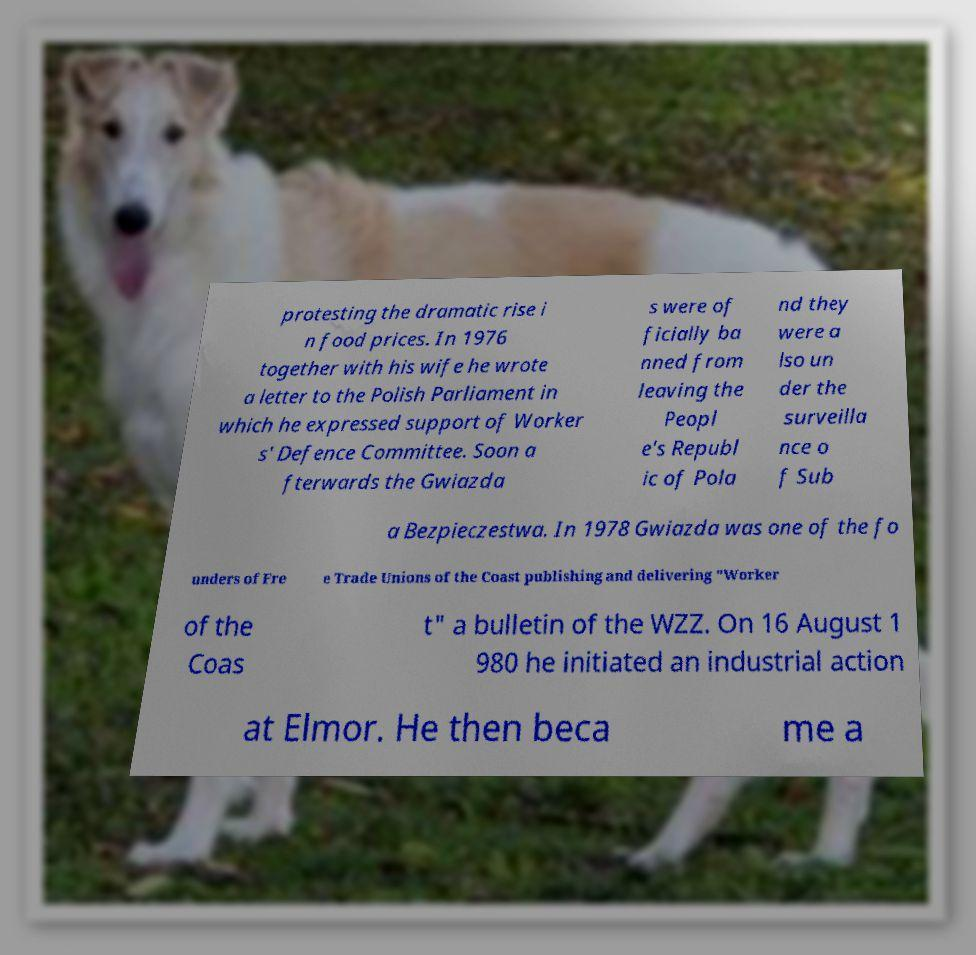There's text embedded in this image that I need extracted. Can you transcribe it verbatim? protesting the dramatic rise i n food prices. In 1976 together with his wife he wrote a letter to the Polish Parliament in which he expressed support of Worker s' Defence Committee. Soon a fterwards the Gwiazda s were of ficially ba nned from leaving the Peopl e's Republ ic of Pola nd they were a lso un der the surveilla nce o f Sub a Bezpieczestwa. In 1978 Gwiazda was one of the fo unders of Fre e Trade Unions of the Coast publishing and delivering "Worker of the Coas t" a bulletin of the WZZ. On 16 August 1 980 he initiated an industrial action at Elmor. He then beca me a 